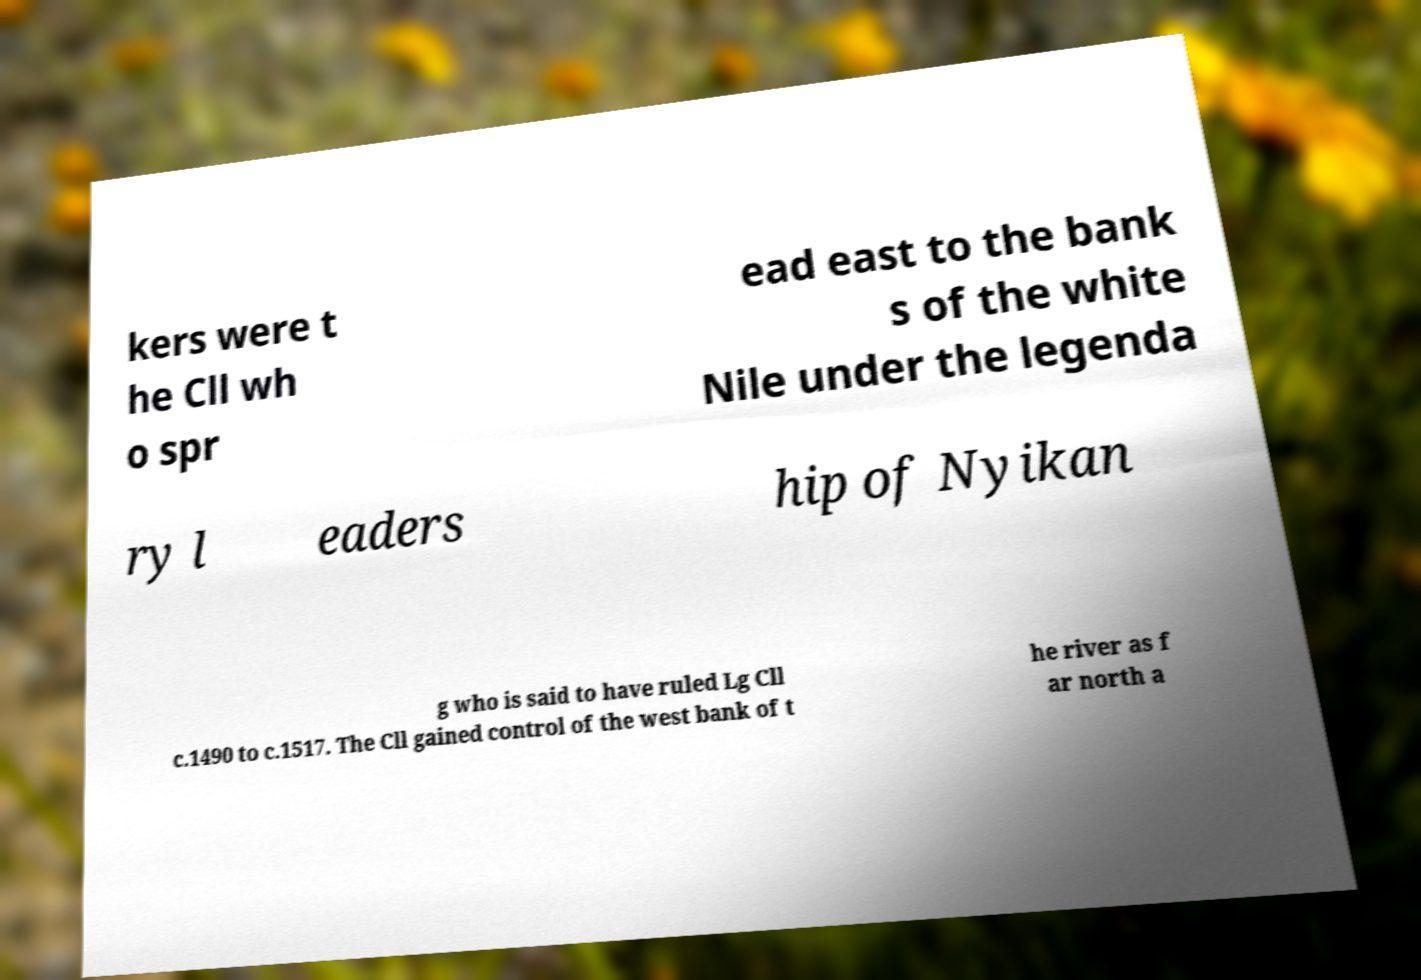For documentation purposes, I need the text within this image transcribed. Could you provide that? kers were t he Cll wh o spr ead east to the bank s of the white Nile under the legenda ry l eaders hip of Nyikan g who is said to have ruled Lg Cll c.1490 to c.1517. The Cll gained control of the west bank of t he river as f ar north a 